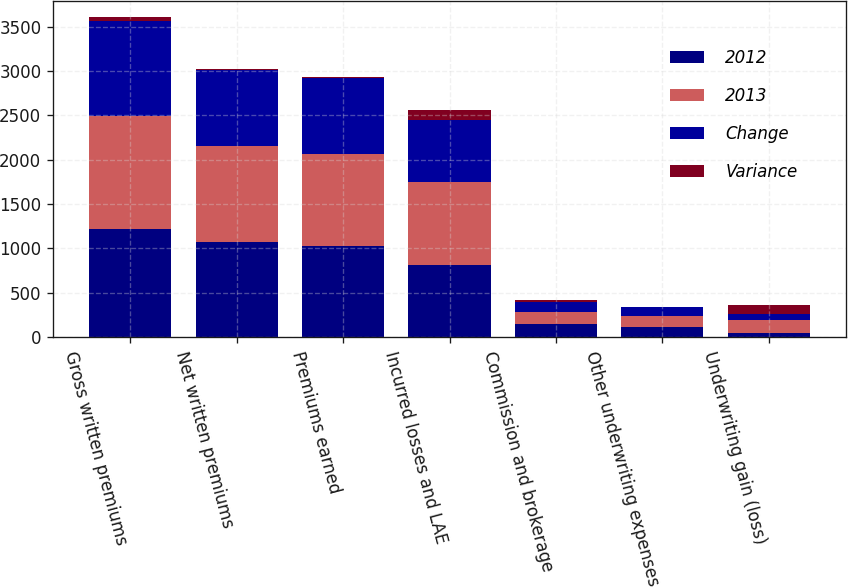Convert chart. <chart><loc_0><loc_0><loc_500><loc_500><stacked_bar_chart><ecel><fcel>Gross written premiums<fcel>Net written premiums<fcel>Premiums earned<fcel>Incurred losses and LAE<fcel>Commission and brokerage<fcel>Other underwriting expenses<fcel>Underwriting gain (loss)<nl><fcel>2012<fcel>1218.4<fcel>1067.3<fcel>1030.3<fcel>811.4<fcel>149.8<fcel>118<fcel>48.9<nl><fcel>2013<fcel>1268.7<fcel>1086.2<fcel>1037.4<fcel>931.5<fcel>133.7<fcel>119.3<fcel>147<nl><fcel>Change<fcel>1073.1<fcel>852.1<fcel>852.4<fcel>700.3<fcel>117.6<fcel>103<fcel>68.5<nl><fcel>Variance<fcel>50.4<fcel>18.9<fcel>7.1<fcel>120<fcel>16.1<fcel>1.3<fcel>98.1<nl></chart> 